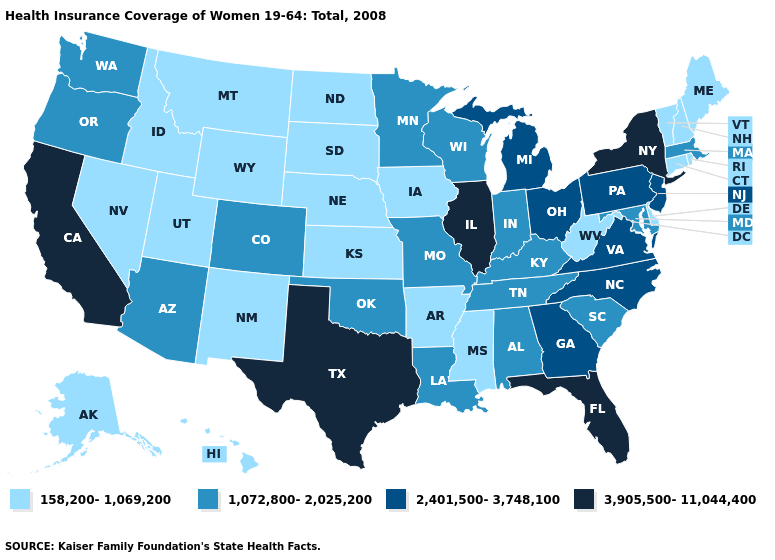Which states have the highest value in the USA?
Be succinct. California, Florida, Illinois, New York, Texas. What is the highest value in the Northeast ?
Answer briefly. 3,905,500-11,044,400. What is the value of Mississippi?
Write a very short answer. 158,200-1,069,200. What is the value of Wisconsin?
Write a very short answer. 1,072,800-2,025,200. Name the states that have a value in the range 158,200-1,069,200?
Be succinct. Alaska, Arkansas, Connecticut, Delaware, Hawaii, Idaho, Iowa, Kansas, Maine, Mississippi, Montana, Nebraska, Nevada, New Hampshire, New Mexico, North Dakota, Rhode Island, South Dakota, Utah, Vermont, West Virginia, Wyoming. Does Delaware have the lowest value in the South?
Concise answer only. Yes. Does New Hampshire have the lowest value in the USA?
Concise answer only. Yes. What is the value of Mississippi?
Answer briefly. 158,200-1,069,200. Which states have the lowest value in the South?
Short answer required. Arkansas, Delaware, Mississippi, West Virginia. Does California have the highest value in the West?
Quick response, please. Yes. What is the value of Texas?
Quick response, please. 3,905,500-11,044,400. What is the lowest value in states that border Florida?
Quick response, please. 1,072,800-2,025,200. What is the lowest value in states that border Delaware?
Write a very short answer. 1,072,800-2,025,200. Is the legend a continuous bar?
Keep it brief. No. What is the highest value in the West ?
Concise answer only. 3,905,500-11,044,400. 